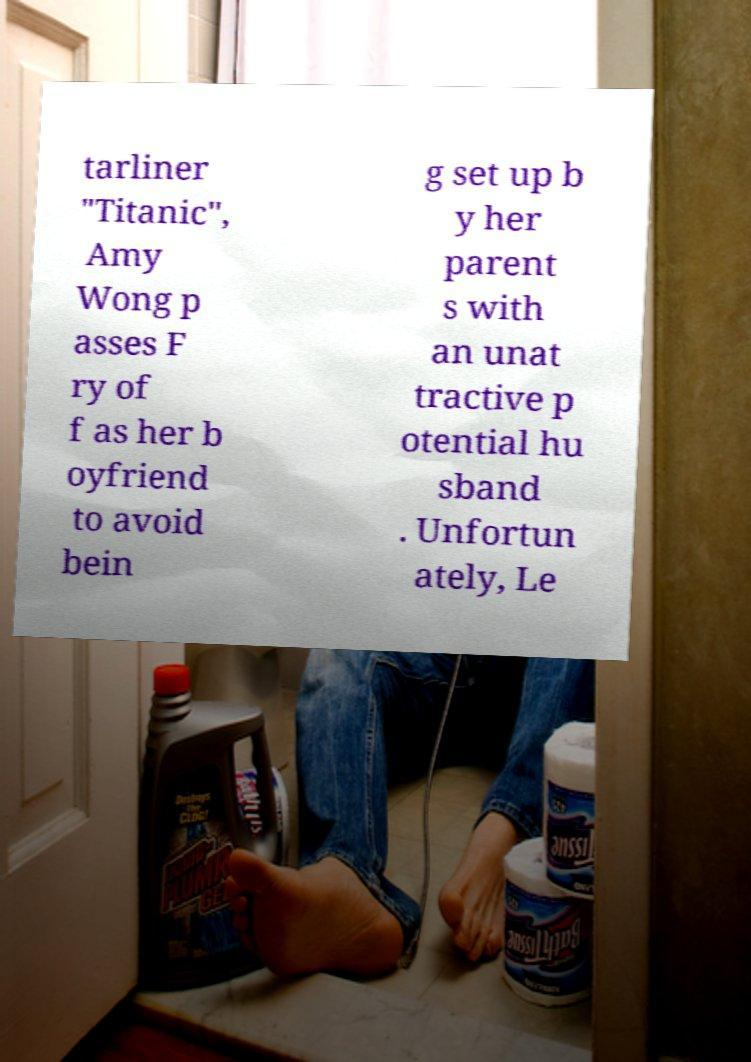There's text embedded in this image that I need extracted. Can you transcribe it verbatim? tarliner "Titanic", Amy Wong p asses F ry of f as her b oyfriend to avoid bein g set up b y her parent s with an unat tractive p otential hu sband . Unfortun ately, Le 